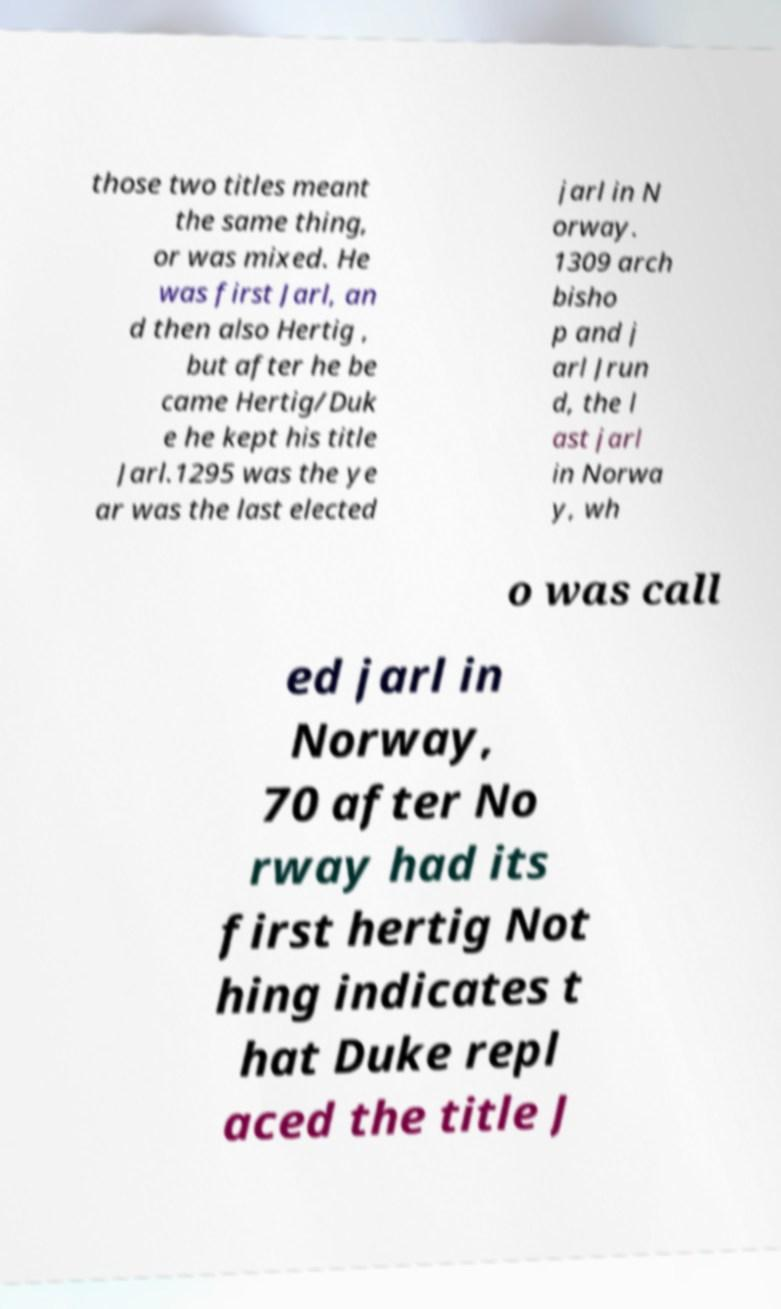Could you assist in decoding the text presented in this image and type it out clearly? those two titles meant the same thing, or was mixed. He was first Jarl, an d then also Hertig , but after he be came Hertig/Duk e he kept his title Jarl.1295 was the ye ar was the last elected jarl in N orway. 1309 arch bisho p and j arl Jrun d, the l ast jarl in Norwa y, wh o was call ed jarl in Norway, 70 after No rway had its first hertig Not hing indicates t hat Duke repl aced the title J 